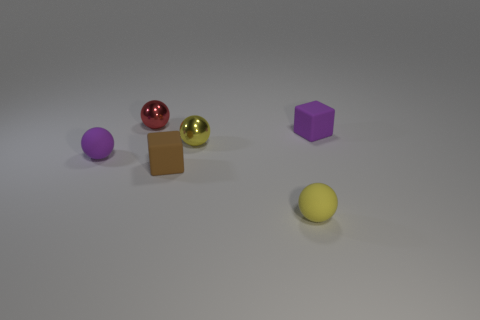Are there more metallic objects that are to the left of the small brown matte block than tiny yellow metallic balls that are to the left of the tiny red object?
Offer a terse response. Yes. How many other objects are the same size as the red metallic sphere?
Give a very brief answer. 5. Is the number of purple objects right of the purple rubber sphere greater than the number of big blue objects?
Give a very brief answer. Yes. What shape is the small purple matte object that is left of the shiny ball in front of the tiny red metal ball?
Ensure brevity in your answer.  Sphere. Are there more yellow metal balls than small red matte objects?
Offer a terse response. Yes. How many tiny matte things are behind the small brown cube and to the right of the small red ball?
Provide a short and direct response. 1. How many small purple rubber blocks are behind the purple thing left of the small yellow rubber sphere?
Your answer should be compact. 1. What number of things are tiny spheres that are behind the small yellow rubber ball or yellow things that are in front of the tiny brown cube?
Your answer should be very brief. 4. What material is the small purple object that is the same shape as the red object?
Provide a short and direct response. Rubber. How many things are either balls that are behind the brown matte block or tiny cyan matte balls?
Provide a short and direct response. 3. 